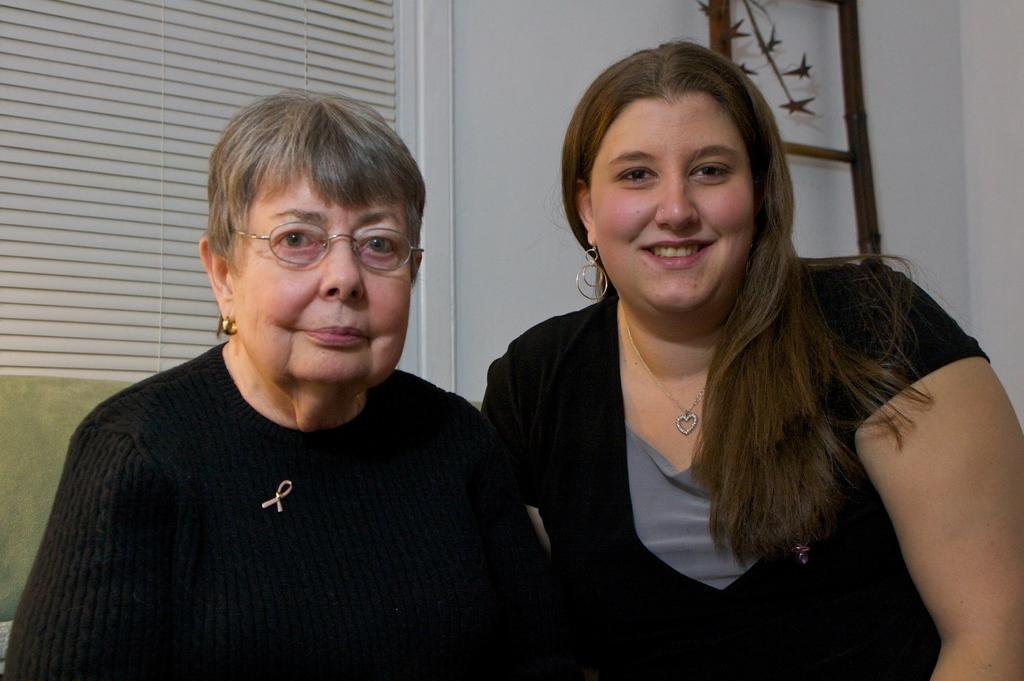How many women are in the image? There are two women in the image. What are the women doing in the image? The women are standing beside each other. What is located behind the women in the image? There is a curtain behind the women. What can be seen on the right side of the image? There appears to be a ladder on the right side of the image. What type of apple is hanging from the curtain in the image? There is no apple present in the image; it only features two women standing beside each other, a curtain, and a ladder. 